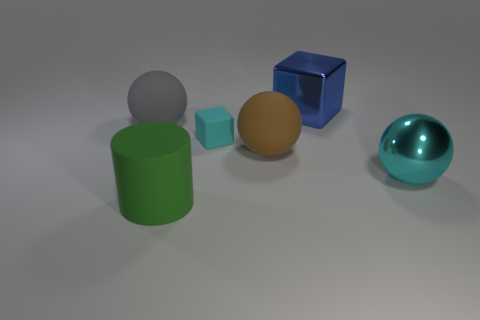Add 2 small blue rubber balls. How many objects exist? 8 Subtract all cylinders. How many objects are left? 5 Add 4 small things. How many small things are left? 5 Add 4 large green matte things. How many large green matte things exist? 5 Subtract 0 brown cubes. How many objects are left? 6 Subtract all large brown matte objects. Subtract all cyan things. How many objects are left? 3 